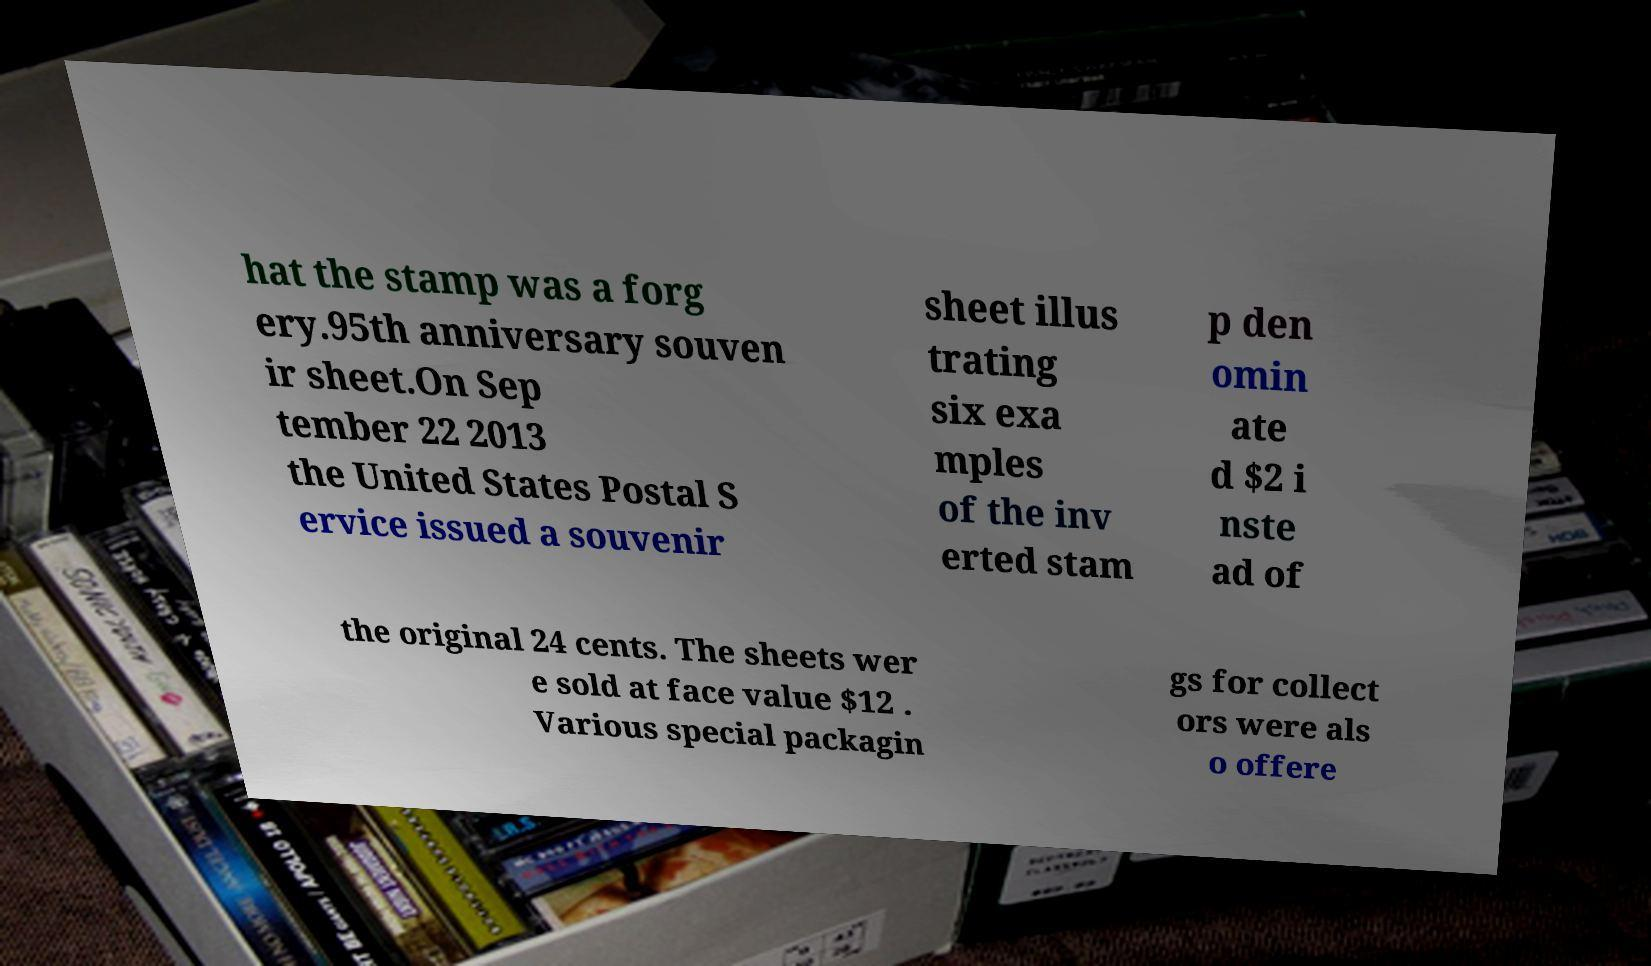There's text embedded in this image that I need extracted. Can you transcribe it verbatim? hat the stamp was a forg ery.95th anniversary souven ir sheet.On Sep tember 22 2013 the United States Postal S ervice issued a souvenir sheet illus trating six exa mples of the inv erted stam p den omin ate d $2 i nste ad of the original 24 cents. The sheets wer e sold at face value $12 . Various special packagin gs for collect ors were als o offere 